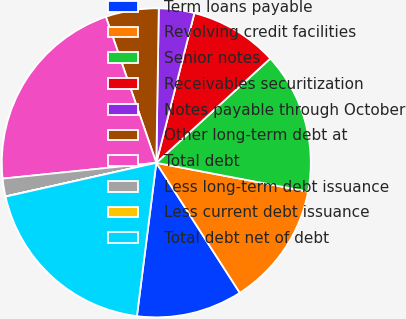<chart> <loc_0><loc_0><loc_500><loc_500><pie_chart><fcel>Term loans payable<fcel>Revolving credit facilities<fcel>Senior notes<fcel>Receivables securitization<fcel>Notes payable through October<fcel>Other long-term debt at<fcel>Total debt<fcel>Less long-term debt issuance<fcel>Less current debt issuance<fcel>Total debt net of debt<nl><fcel>11.09%<fcel>12.93%<fcel>14.78%<fcel>9.24%<fcel>3.71%<fcel>5.55%<fcel>21.34%<fcel>1.86%<fcel>0.02%<fcel>19.49%<nl></chart> 